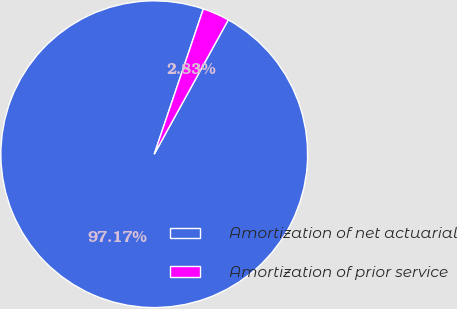Convert chart to OTSL. <chart><loc_0><loc_0><loc_500><loc_500><pie_chart><fcel>Amortization of net actuarial<fcel>Amortization of prior service<nl><fcel>97.17%<fcel>2.83%<nl></chart> 